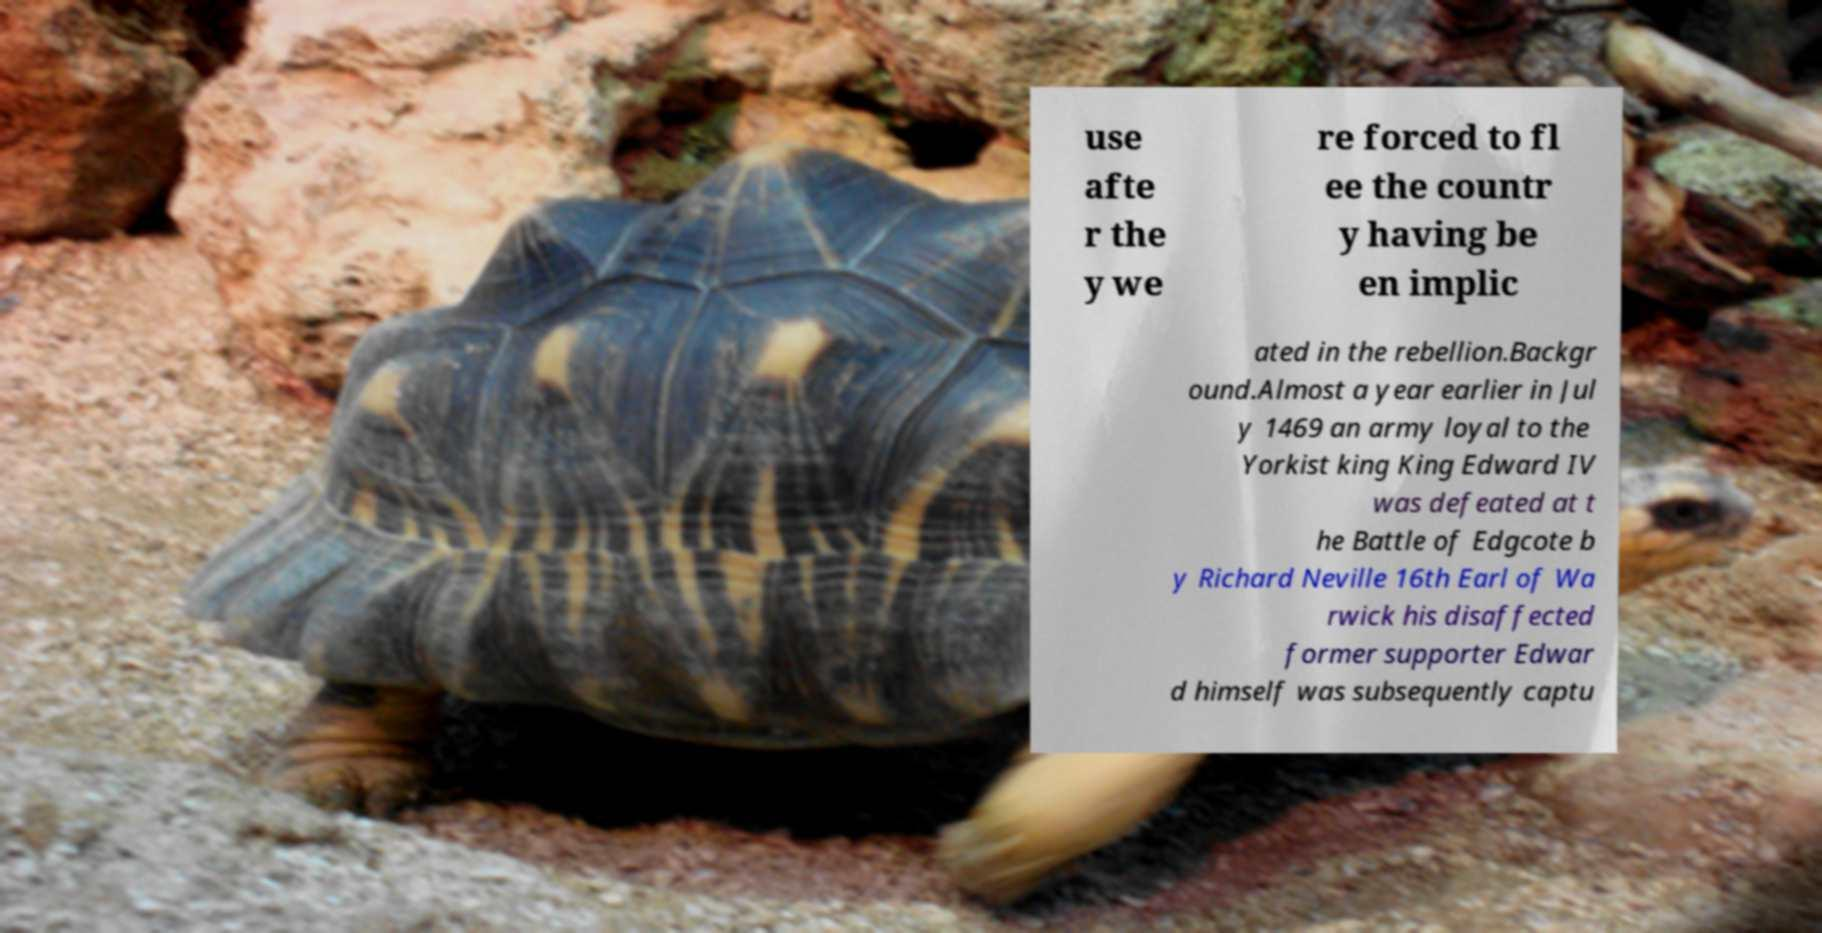I need the written content from this picture converted into text. Can you do that? use afte r the y we re forced to fl ee the countr y having be en implic ated in the rebellion.Backgr ound.Almost a year earlier in Jul y 1469 an army loyal to the Yorkist king King Edward IV was defeated at t he Battle of Edgcote b y Richard Neville 16th Earl of Wa rwick his disaffected former supporter Edwar d himself was subsequently captu 